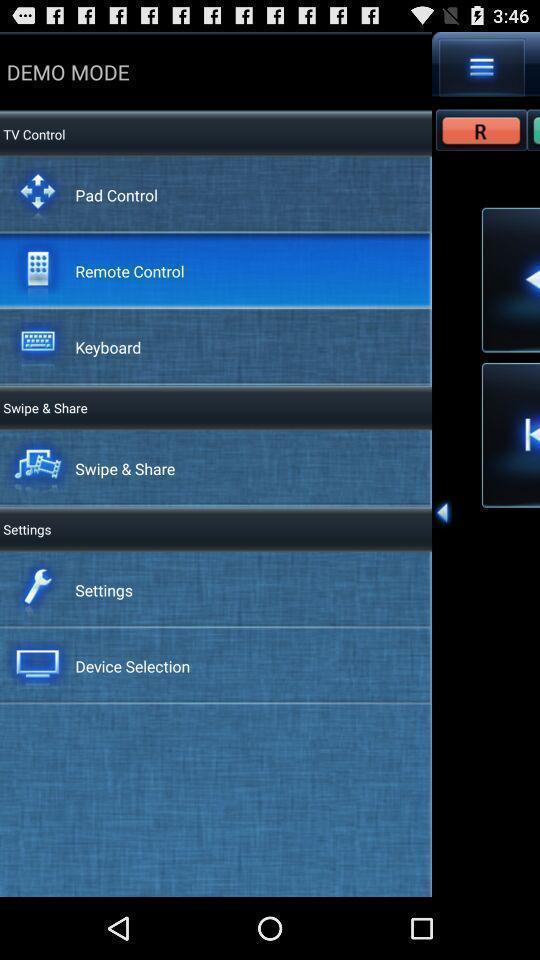Tell me what you see in this picture. Page showing the options for demo mode. 